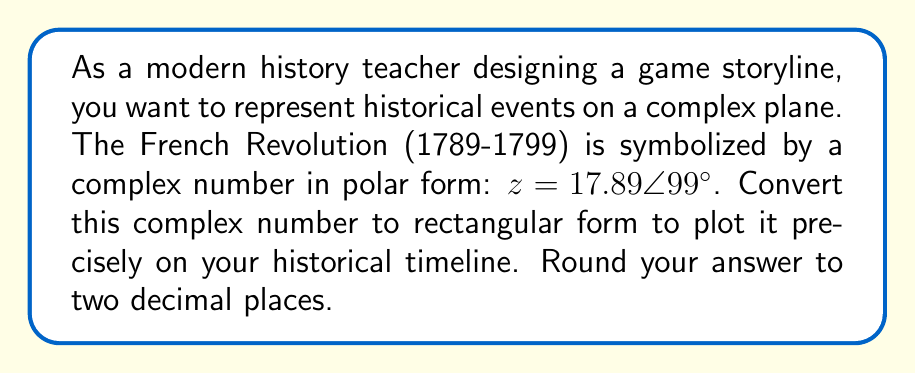Could you help me with this problem? To convert a complex number from polar form to rectangular form, we use the following formulas:

$$ x = r \cos(\theta) $$
$$ y = r \sin(\theta) $$

Where $r$ is the magnitude (modulus) and $\theta$ is the angle (argument) in radians.

Given: $z = 17.89 \angle 99°$

Step 1: Convert the angle from degrees to radians.
$$ \theta = 99° \times \frac{\pi}{180°} = 1.7278 \text{ radians} $$

Step 2: Calculate the real part (x).
$$ x = 17.89 \cos(1.7278) = -2.7799 $$

Step 3: Calculate the imaginary part (y).
$$ y = 17.89 \sin(1.7278) = 17.6595 $$

Step 4: Round both values to two decimal places.
$$ x \approx -2.78 $$
$$ y \approx 17.66 $$

Step 5: Express the result in the form $a + bi$.
Answer: $z \approx -2.78 + 17.66i$ 